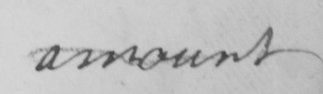What text is written in this handwritten line? amount 